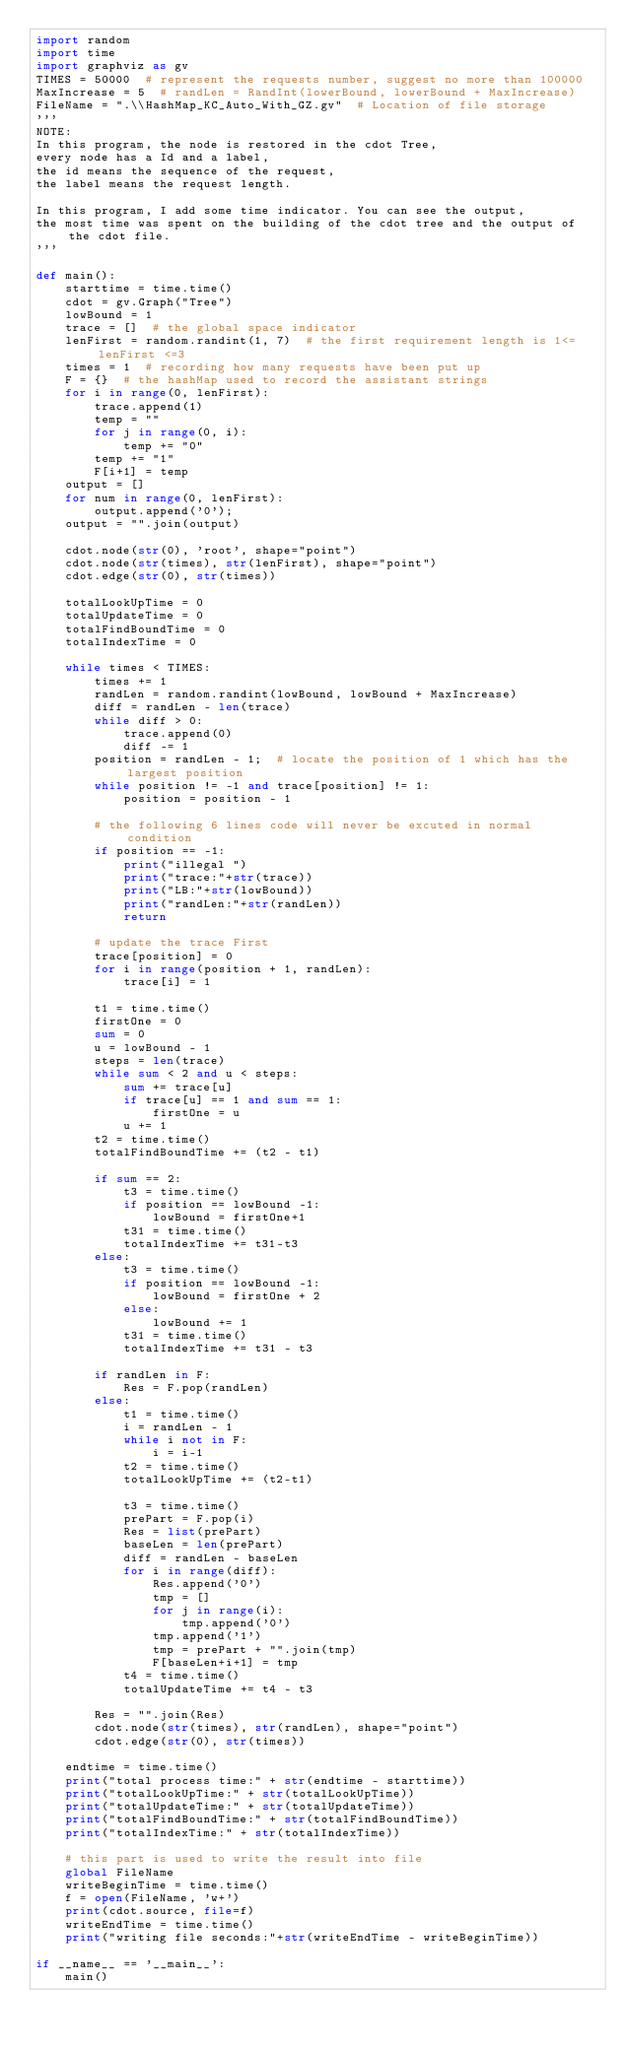Convert code to text. <code><loc_0><loc_0><loc_500><loc_500><_Python_>import random
import time
import graphviz as gv
TIMES = 50000  # represent the requests number, suggest no more than 100000
MaxIncrease = 5  # randLen = RandInt(lowerBound, lowerBound + MaxIncrease)
FileName = ".\\HashMap_KC_Auto_With_GZ.gv"  # Location of file storage
'''
NOTE:
In this program, the node is restored in the cdot Tree, 
every node has a Id and a label, 
the id means the sequence of the request, 
the label means the request length.

In this program, I add some time indicator. You can see the output,
the most time was spent on the building of the cdot tree and the output of the cdot file.
'''

def main():
    starttime = time.time()
    cdot = gv.Graph("Tree")
    lowBound = 1
    trace = []  # the global space indicator
    lenFirst = random.randint(1, 7)  # the first requirement length is 1<= lenFirst <=3
    times = 1  # recording how many requests have been put up
    F = {}  # the hashMap used to record the assistant strings
    for i in range(0, lenFirst):
        trace.append(1)
        temp = ""
        for j in range(0, i):
            temp += "0"
        temp += "1"
        F[i+1] = temp
    output = []
    for num in range(0, lenFirst):
        output.append('0');
    output = "".join(output)

    cdot.node(str(0), 'root', shape="point")
    cdot.node(str(times), str(lenFirst), shape="point")
    cdot.edge(str(0), str(times))

    totalLookUpTime = 0
    totalUpdateTime = 0
    totalFindBoundTime = 0
    totalIndexTime = 0

    while times < TIMES:
        times += 1
        randLen = random.randint(lowBound, lowBound + MaxIncrease)
        diff = randLen - len(trace)
        while diff > 0:
            trace.append(0)
            diff -= 1
        position = randLen - 1;  # locate the position of 1 which has the largest position
        while position != -1 and trace[position] != 1:
            position = position - 1

        # the following 6 lines code will never be excuted in normal condition
        if position == -1:
            print("illegal ")
            print("trace:"+str(trace))
            print("LB:"+str(lowBound))
            print("randLen:"+str(randLen))
            return

        # update the trace First
        trace[position] = 0
        for i in range(position + 1, randLen):
            trace[i] = 1

        t1 = time.time()
        firstOne = 0
        sum = 0
        u = lowBound - 1
        steps = len(trace)
        while sum < 2 and u < steps:
            sum += trace[u]
            if trace[u] == 1 and sum == 1:
                firstOne = u
            u += 1
        t2 = time.time()
        totalFindBoundTime += (t2 - t1)

        if sum == 2:
            t3 = time.time()
            if position == lowBound -1:
                lowBound = firstOne+1
            t31 = time.time()
            totalIndexTime += t31-t3
        else:
            t3 = time.time()
            if position == lowBound -1:
                lowBound = firstOne + 2
            else:
                lowBound += 1
            t31 = time.time()
            totalIndexTime += t31 - t3

        if randLen in F:
            Res = F.pop(randLen)
        else:
            t1 = time.time()
            i = randLen - 1
            while i not in F:
                i = i-1
            t2 = time.time()
            totalLookUpTime += (t2-t1)

            t3 = time.time()
            prePart = F.pop(i)
            Res = list(prePart)
            baseLen = len(prePart)
            diff = randLen - baseLen
            for i in range(diff):
                Res.append('0')
                tmp = []
                for j in range(i):
                    tmp.append('0')
                tmp.append('1')
                tmp = prePart + "".join(tmp)
                F[baseLen+i+1] = tmp
            t4 = time.time()
            totalUpdateTime += t4 - t3

        Res = "".join(Res)
        cdot.node(str(times), str(randLen), shape="point")
        cdot.edge(str(0), str(times))

    endtime = time.time()
    print("total process time:" + str(endtime - starttime))
    print("totalLookUpTime:" + str(totalLookUpTime))
    print("totalUpdateTime:" + str(totalUpdateTime))
    print("totalFindBoundTime:" + str(totalFindBoundTime))
    print("totalIndexTime:" + str(totalIndexTime))

    # this part is used to write the result into file
    global FileName
    writeBeginTime = time.time()
    f = open(FileName, 'w+')
    print(cdot.source, file=f)
    writeEndTime = time.time()
    print("writing file seconds:"+str(writeEndTime - writeBeginTime))

if __name__ == '__main__':
    main()</code> 